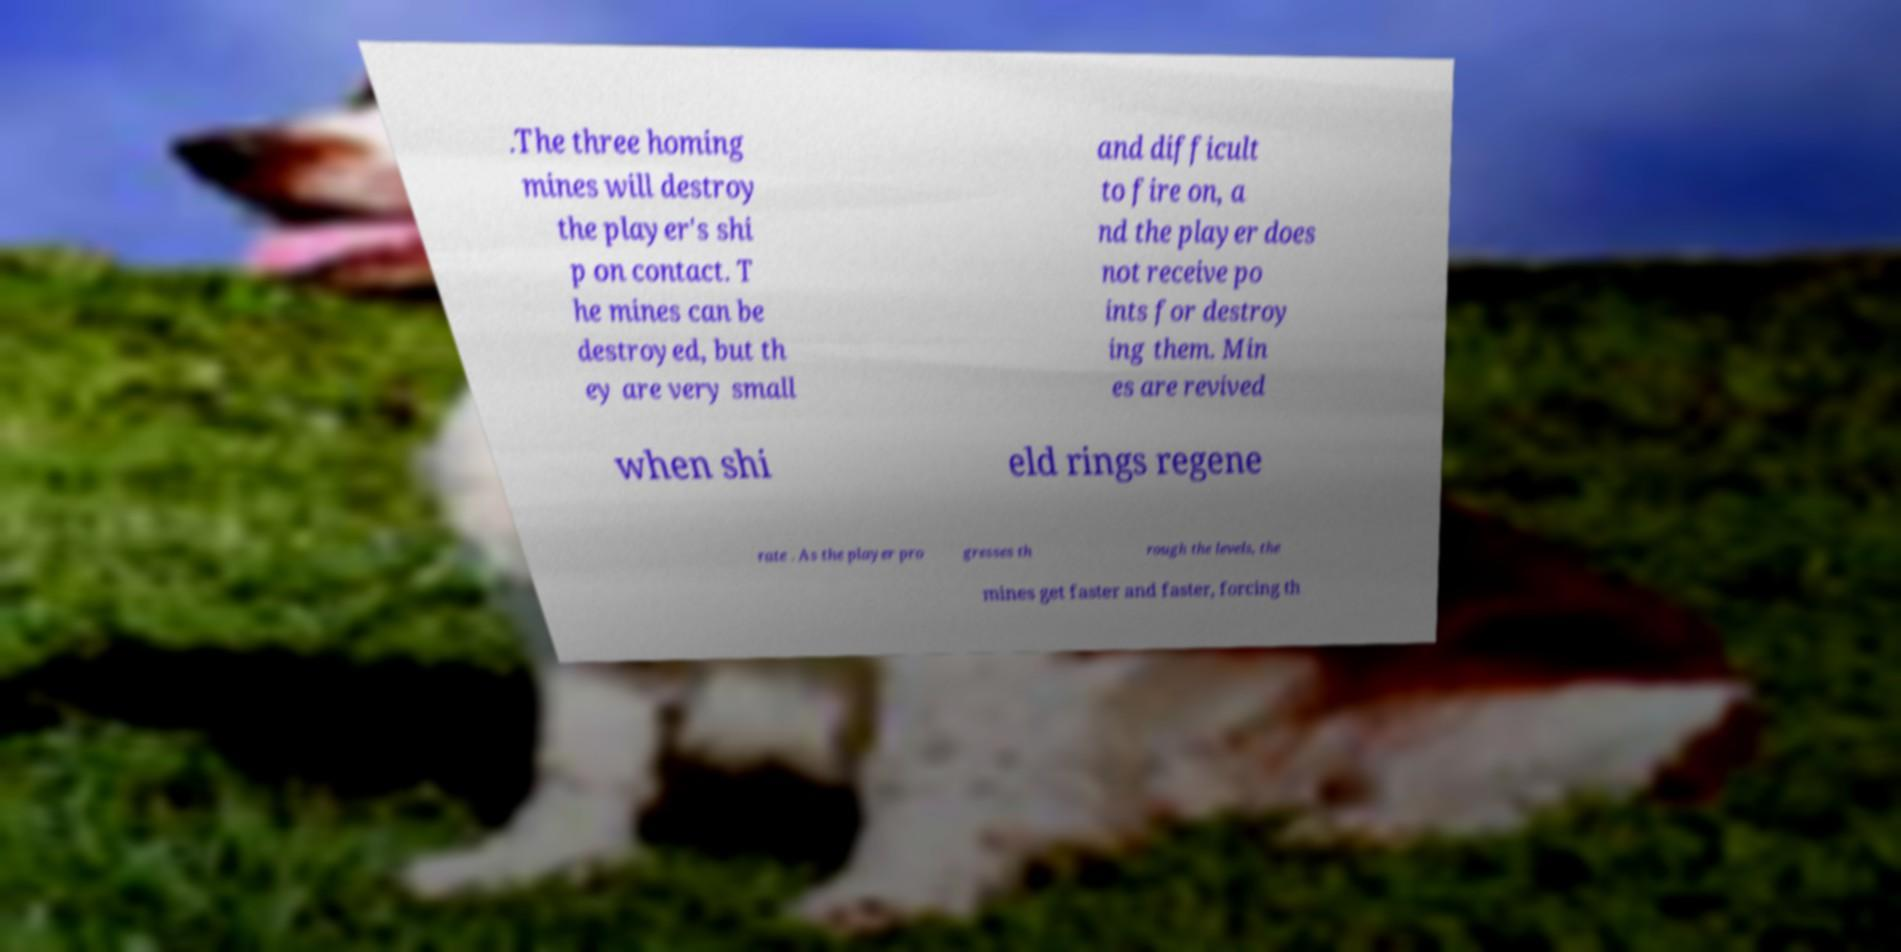There's text embedded in this image that I need extracted. Can you transcribe it verbatim? .The three homing mines will destroy the player's shi p on contact. T he mines can be destroyed, but th ey are very small and difficult to fire on, a nd the player does not receive po ints for destroy ing them. Min es are revived when shi eld rings regene rate . As the player pro gresses th rough the levels, the mines get faster and faster, forcing th 